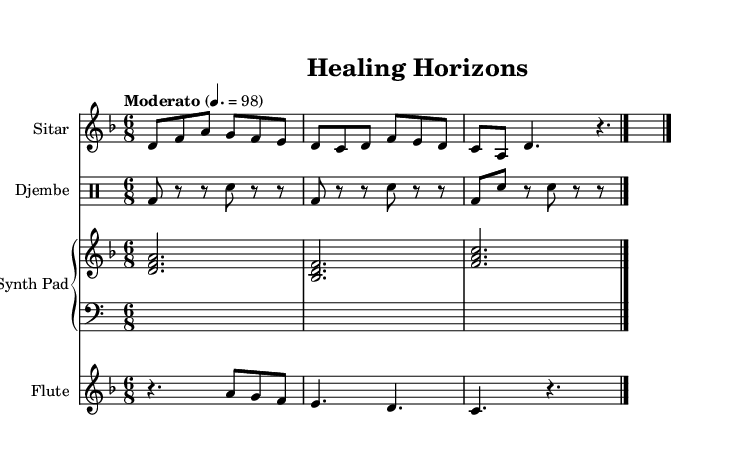What is the key signature of this music? The key signature is indicated at the beginning of the staff. Here, it shows one flat which corresponds to the key of D minor.
Answer: D minor What is the time signature of this music? The time signature is shown after the key signature and is represented as 6/8. This means there are six eighth notes in a measure.
Answer: 6/8 What is the tempo marking for the piece? The tempo marking indicates that the piece should be played at a speed of 98 beats per minute. This is noted as “Moderato” in the score.
Answer: Moderato 4. = 98 How many instruments are featured in this score? By counting the distinct staves, there are a total of four different instruments presented in the score: sitar, djembe, synth pad, and flute.
Answer: Four What type of instrument is used for the rhythm in this piece? The rhythmic part is primarily played by the djembe, which is denoted in the drum staff with a specific drumming notation.
Answer: Djembe Which sections contain rests in the flute part? The flute part contains rests marked in the second and third measures. The rest is indicated as 'r' in the notation, showing silence.
Answer: Second and third measures What characterizes the use of traditional instruments in this fusion? The score features traditional instruments like the sitar and djembe combined with modern production elements, such as the synth pad, creating a layer of emotional depth while retaining cultural authenticity.
Answer: Sitar and djembe 